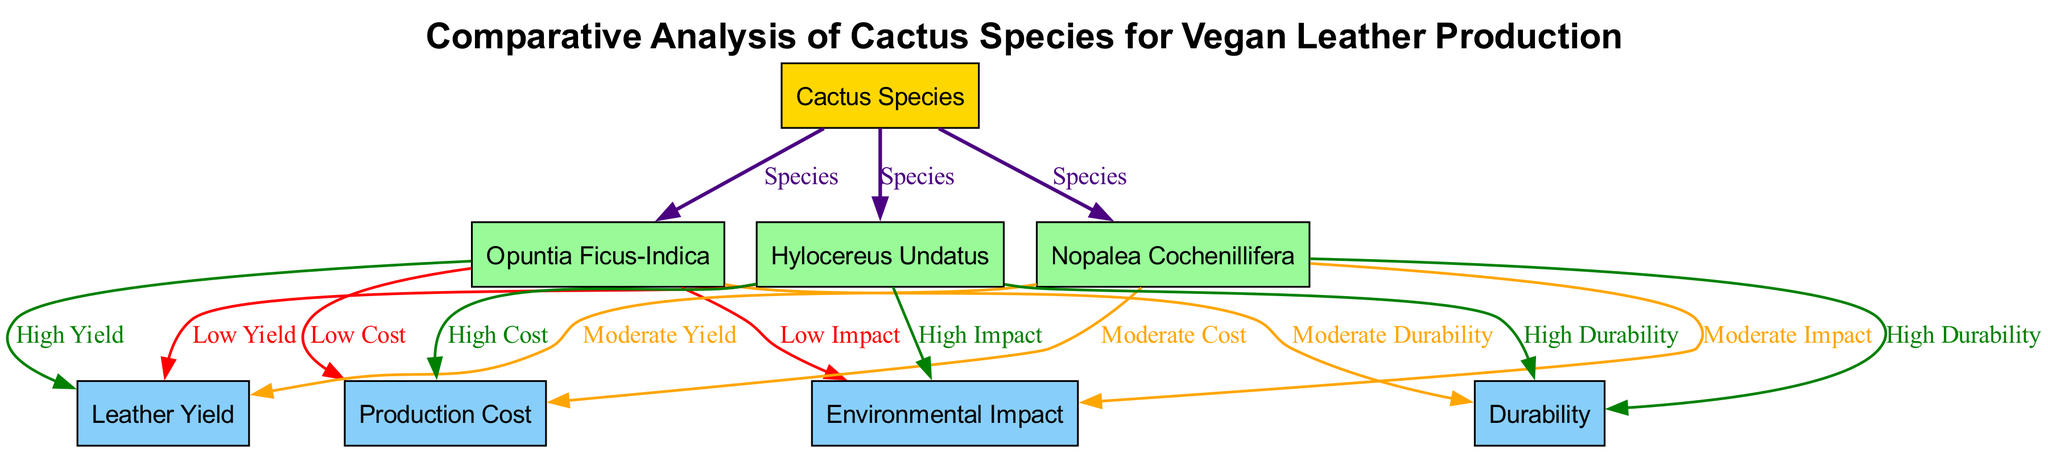What are the three cactus species analyzed in the diagram? The three cactus species identified in the diagram are Opuntia Ficus-Indica, Nopalea Cochenillifera, and Hylocereus Undatus, represented as nodes connected to the main node "Cactus Species."
Answer: Opuntia Ficus-Indica, Nopalea Cochenillifera, Hylocereus Undatus Which cactus species has the highest leather yield? According to the edges connected to the nodes for leather yield, Opuntia Ficus-Indica is labeled with "High Yield," indicating it has the highest leather yield among the species analyzed.
Answer: Opuntia Ficus-Indica What is the environmental impact rating of Hylocereus Undatus? The edge connecting Hylocereus Undatus to the Environmental Impact node indicates a "High Impact," denoting its negative environmental implications relative to the other species.
Answer: High Impact Which cactus species has the lowest production cost? The edge from Opuntia Ficus-Indica to the Production Cost node states "Low Cost," making it the cactus species with the lowest production cost.
Answer: Opuntia Ficus-Indica What is the durability of Nopalea Cochenillifera? The edge from Nopalea Cochenillifera to the Durability node indicates "High Durability," signifying that this species provides substantial durability in leather production.
Answer: High Durability Which species has the highest production cost? Observing the edges leading to the Production Cost node, Hylocereus Undatus is connected with "High Cost," marking it as the species with the highest production cost.
Answer: Hylocereus Undatus How many cactus species are evaluated in the diagram? The diagram illustrates three cactus species each linked to the main node by specific edges, confirming the count of species evaluated.
Answer: Three What is the relationship between Nopalea Cochenillifera and Environmental Impact? The edge shows that Nopalea Cochenillifera is associated with "Moderate Impact," thus indicating a moderate environmental effect compared to others.
Answer: Moderate Impact Which species demonstrates a combination of high durability but also high production cost? The species Hylocereus Undatus exhibits "High Durability" and is connected to "High Cost," illustrating its dual characteristics in production attributes.
Answer: Hylocereus Undatus 